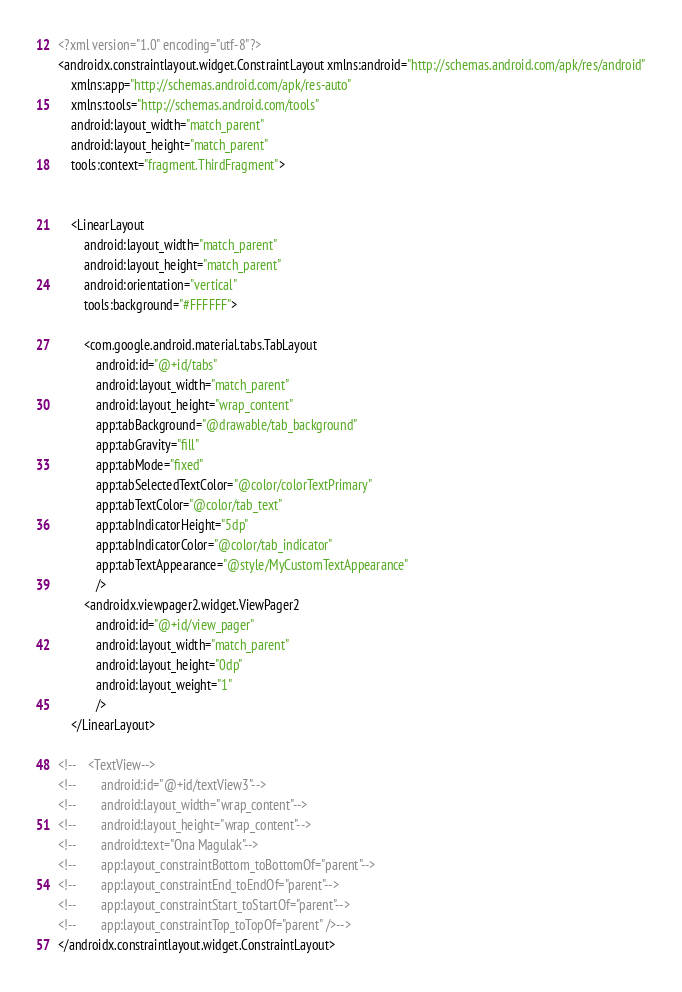<code> <loc_0><loc_0><loc_500><loc_500><_XML_><?xml version="1.0" encoding="utf-8"?>
<androidx.constraintlayout.widget.ConstraintLayout xmlns:android="http://schemas.android.com/apk/res/android"
    xmlns:app="http://schemas.android.com/apk/res-auto"
    xmlns:tools="http://schemas.android.com/tools"
    android:layout_width="match_parent"
    android:layout_height="match_parent"
    tools:context="fragment.ThirdFragment">


    <LinearLayout
        android:layout_width="match_parent"
        android:layout_height="match_parent"
        android:orientation="vertical"
        tools:background="#FFFFFF">

        <com.google.android.material.tabs.TabLayout
            android:id="@+id/tabs"
            android:layout_width="match_parent"
            android:layout_height="wrap_content"
            app:tabBackground="@drawable/tab_background"
            app:tabGravity="fill"
            app:tabMode="fixed"
            app:tabSelectedTextColor="@color/colorTextPrimary"
            app:tabTextColor="@color/tab_text"
            app:tabIndicatorHeight="5dp"
            app:tabIndicatorColor="@color/tab_indicator"
            app:tabTextAppearance="@style/MyCustomTextAppearance"
            />
        <androidx.viewpager2.widget.ViewPager2
            android:id="@+id/view_pager"
            android:layout_width="match_parent"
            android:layout_height="0dp"
            android:layout_weight="1"
            />
    </LinearLayout>

<!--    <TextView-->
<!--        android:id="@+id/textView3"-->
<!--        android:layout_width="wrap_content"-->
<!--        android:layout_height="wrap_content"-->
<!--        android:text="Ona Magulak"-->
<!--        app:layout_constraintBottom_toBottomOf="parent"-->
<!--        app:layout_constraintEnd_toEndOf="parent"-->
<!--        app:layout_constraintStart_toStartOf="parent"-->
<!--        app:layout_constraintTop_toTopOf="parent" />-->
</androidx.constraintlayout.widget.ConstraintLayout></code> 